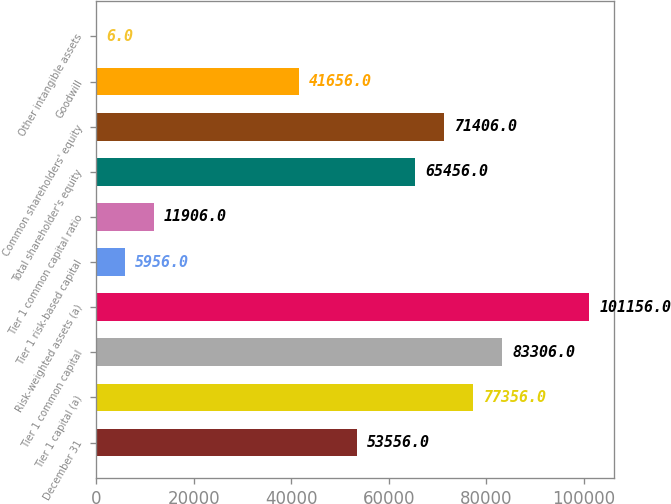<chart> <loc_0><loc_0><loc_500><loc_500><bar_chart><fcel>December 31<fcel>Tier 1 capital (a)<fcel>Tier 1 common capital<fcel>Risk-weighted assets (a)<fcel>Tier 1 risk-based capital<fcel>Tier 1 common capital ratio<fcel>Total shareholder's equity<fcel>Common shareholders' equity<fcel>Goodwill<fcel>Other intangible assets<nl><fcel>53556<fcel>77356<fcel>83306<fcel>101156<fcel>5956<fcel>11906<fcel>65456<fcel>71406<fcel>41656<fcel>6<nl></chart> 